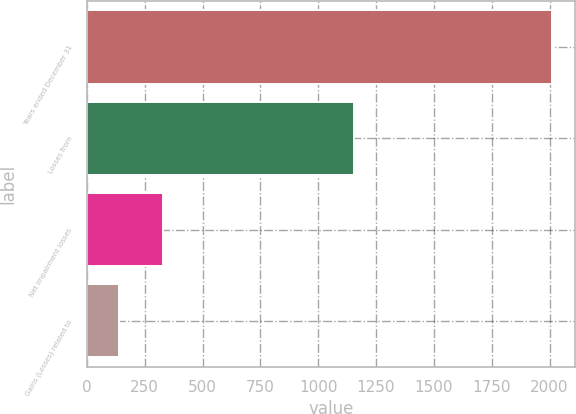Convert chart. <chart><loc_0><loc_0><loc_500><loc_500><bar_chart><fcel>Years ended December 31<fcel>Losses from<fcel>Net impairment losses<fcel>Gains (Losses) related to<nl><fcel>2009<fcel>1155<fcel>327.8<fcel>141<nl></chart> 